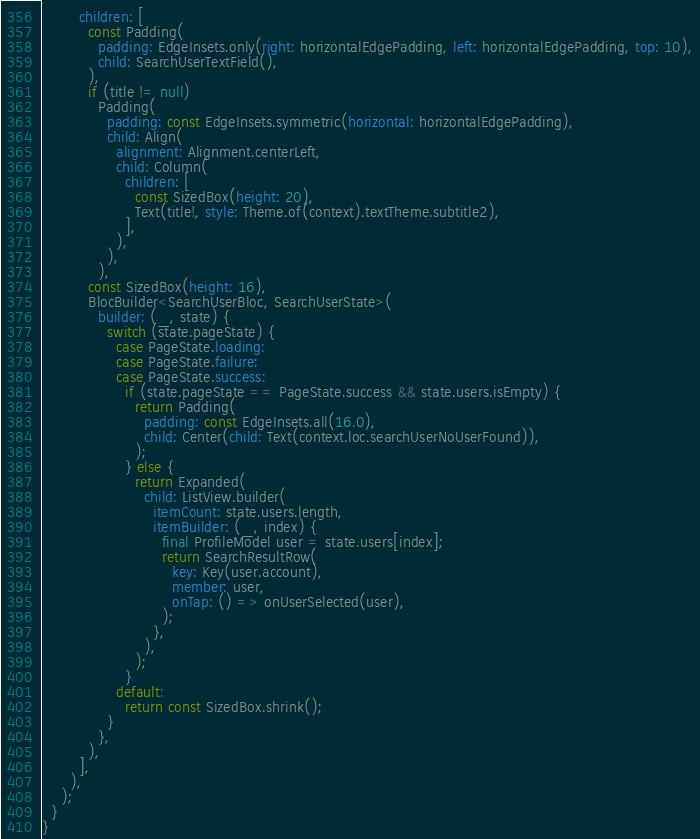Convert code to text. <code><loc_0><loc_0><loc_500><loc_500><_Dart_>        children: [
          const Padding(
            padding: EdgeInsets.only(right: horizontalEdgePadding, left: horizontalEdgePadding, top: 10),
            child: SearchUserTextField(),
          ),
          if (title != null)
            Padding(
              padding: const EdgeInsets.symmetric(horizontal: horizontalEdgePadding),
              child: Align(
                alignment: Alignment.centerLeft,
                child: Column(
                  children: [
                    const SizedBox(height: 20),
                    Text(title!, style: Theme.of(context).textTheme.subtitle2),
                  ],
                ),
              ),
            ),
          const SizedBox(height: 16),
          BlocBuilder<SearchUserBloc, SearchUserState>(
            builder: (_, state) {
              switch (state.pageState) {
                case PageState.loading:
                case PageState.failure:
                case PageState.success:
                  if (state.pageState == PageState.success && state.users.isEmpty) {
                    return Padding(
                      padding: const EdgeInsets.all(16.0),
                      child: Center(child: Text(context.loc.searchUserNoUserFound)),
                    );
                  } else {
                    return Expanded(
                      child: ListView.builder(
                        itemCount: state.users.length,
                        itemBuilder: (_, index) {
                          final ProfileModel user = state.users[index];
                          return SearchResultRow(
                            key: Key(user.account),
                            member: user,
                            onTap: () => onUserSelected(user),
                          );
                        },
                      ),
                    );
                  }
                default:
                  return const SizedBox.shrink();
              }
            },
          ),
        ],
      ),
    );
  }
}
</code> 